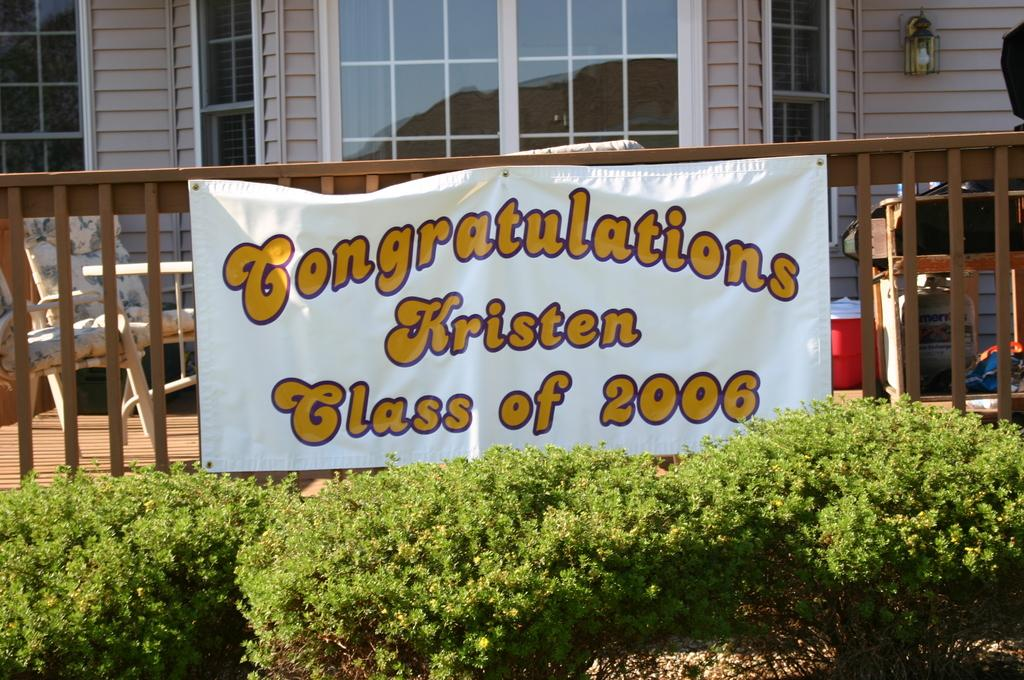What is hanging or displayed in the image? There is a banner in the image. What type of natural elements are present in the image? There are plants in the image. What type of furniture is visible in the image? There is a chair in the image. What type of artificial light source is visible in the image? There is a light in the image. What type of man-made structure is visible in the image? There is a building in the image. Can you tell me how many sponges are depicted on the banner in the image? There are no sponges depicted on the banner or anywhere else in the image. What type of writer is shown working on the chair in the image? There is no writer or any person shown working on the chair in the image. 